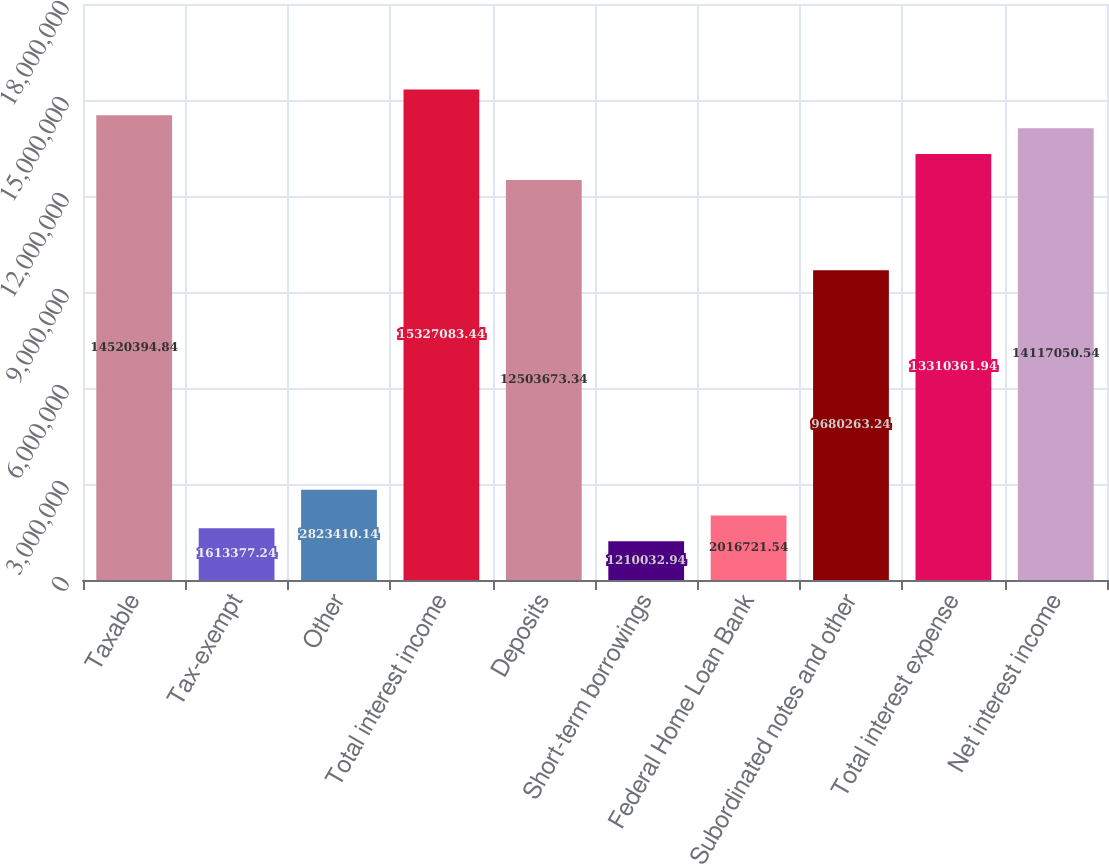Convert chart. <chart><loc_0><loc_0><loc_500><loc_500><bar_chart><fcel>Taxable<fcel>Tax-exempt<fcel>Other<fcel>Total interest income<fcel>Deposits<fcel>Short-term borrowings<fcel>Federal Home Loan Bank<fcel>Subordinated notes and other<fcel>Total interest expense<fcel>Net interest income<nl><fcel>1.45204e+07<fcel>1.61338e+06<fcel>2.82341e+06<fcel>1.53271e+07<fcel>1.25037e+07<fcel>1.21003e+06<fcel>2.01672e+06<fcel>9.68026e+06<fcel>1.33104e+07<fcel>1.41171e+07<nl></chart> 